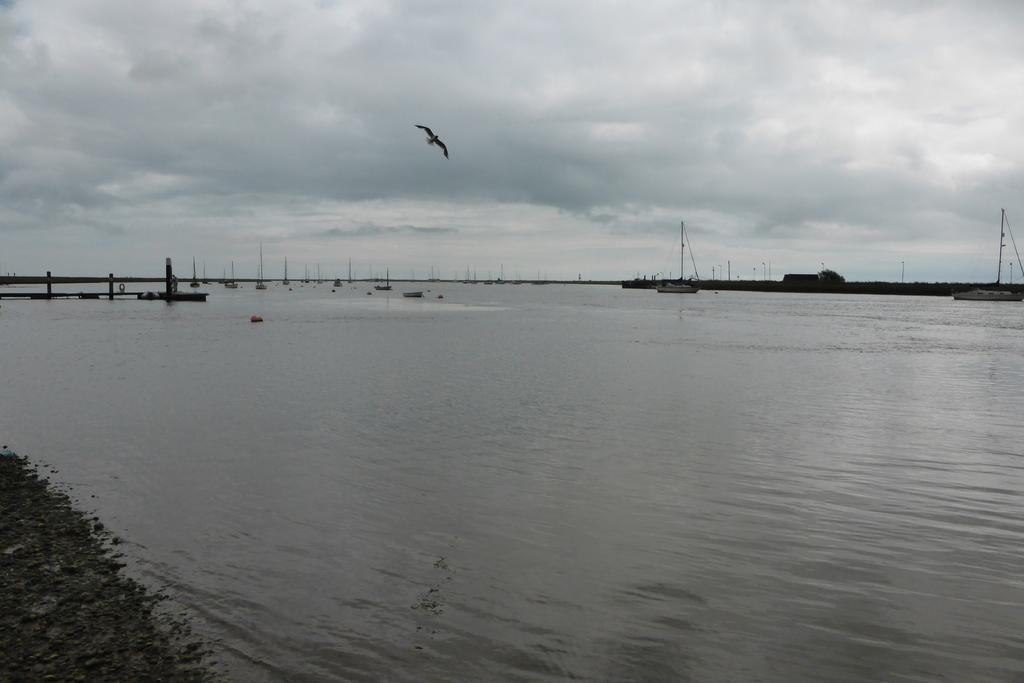Describe this image in one or two sentences. In the image I can see boats on the water. In the background I can see boatyard, the sky and some other objects. 